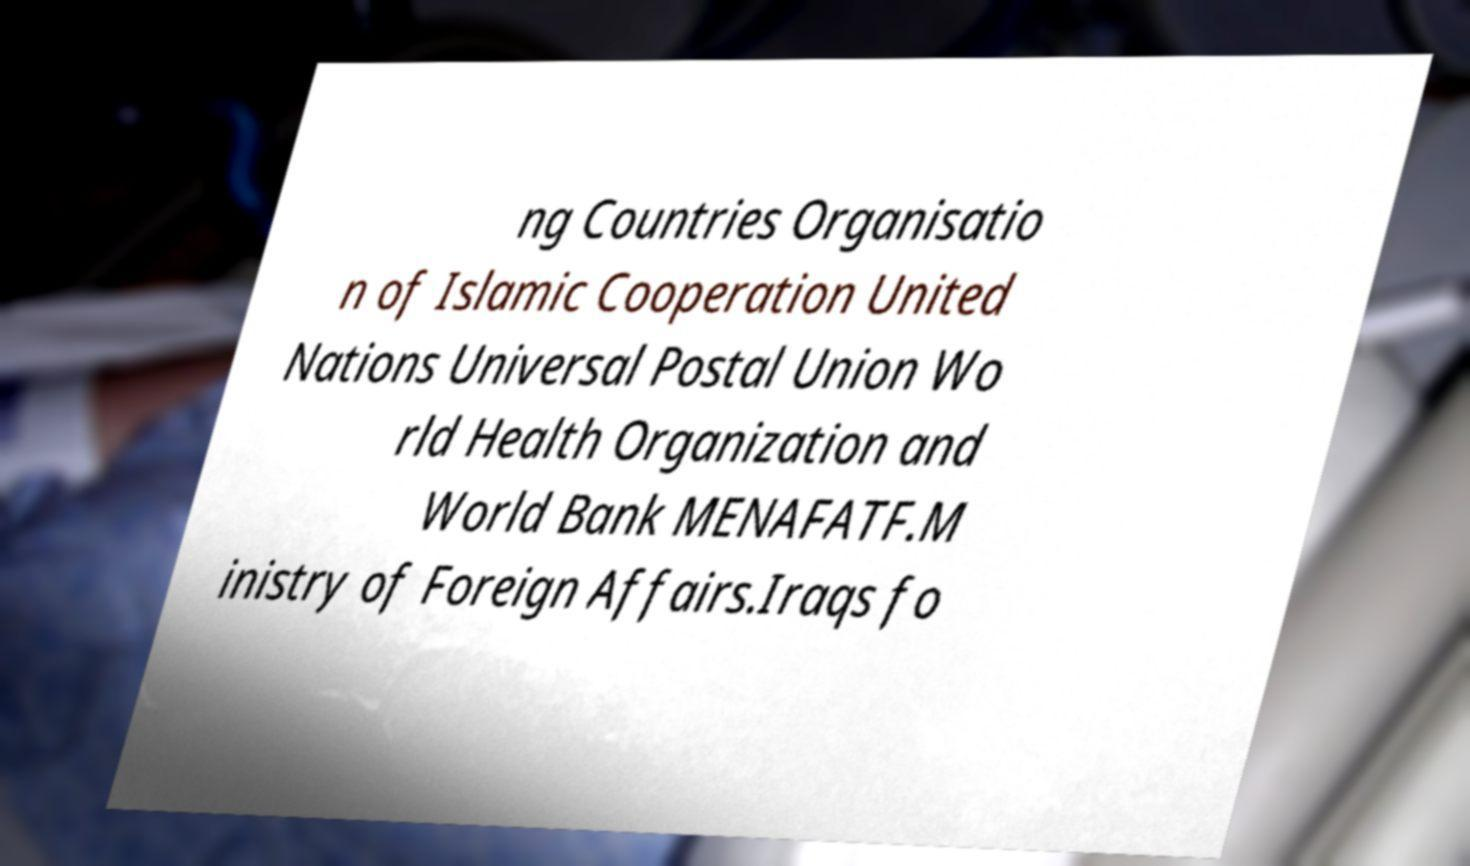Could you assist in decoding the text presented in this image and type it out clearly? ng Countries Organisatio n of Islamic Cooperation United Nations Universal Postal Union Wo rld Health Organization and World Bank MENAFATF.M inistry of Foreign Affairs.Iraqs fo 